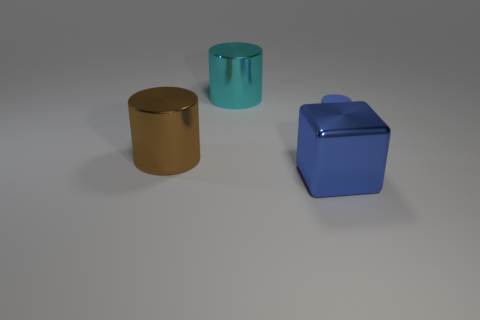How many big shiny cylinders are in front of the metallic object to the left of the big cylinder on the right side of the large brown thing?
Provide a short and direct response. 0. There is a big shiny object behind the big brown thing; does it have the same color as the large block in front of the blue rubber cylinder?
Offer a terse response. No. Is there any other thing of the same color as the large block?
Provide a short and direct response. Yes. What color is the object in front of the thing that is left of the cyan cylinder?
Offer a terse response. Blue. Are any tiny blue matte things visible?
Keep it short and to the point. Yes. There is a object that is both in front of the cyan cylinder and left of the blue block; what is its color?
Your answer should be compact. Brown. There is a blue matte object that is in front of the cyan shiny cylinder; does it have the same size as the blue thing in front of the tiny blue cylinder?
Offer a very short reply. No. How many other things are there of the same size as the cyan metal object?
Keep it short and to the point. 2. What number of small rubber cylinders are behind the big shiny thing that is behind the tiny cylinder?
Make the answer very short. 0. Is the number of big blue metallic objects on the right side of the blue shiny object less than the number of large cyan metal objects?
Ensure brevity in your answer.  Yes. 